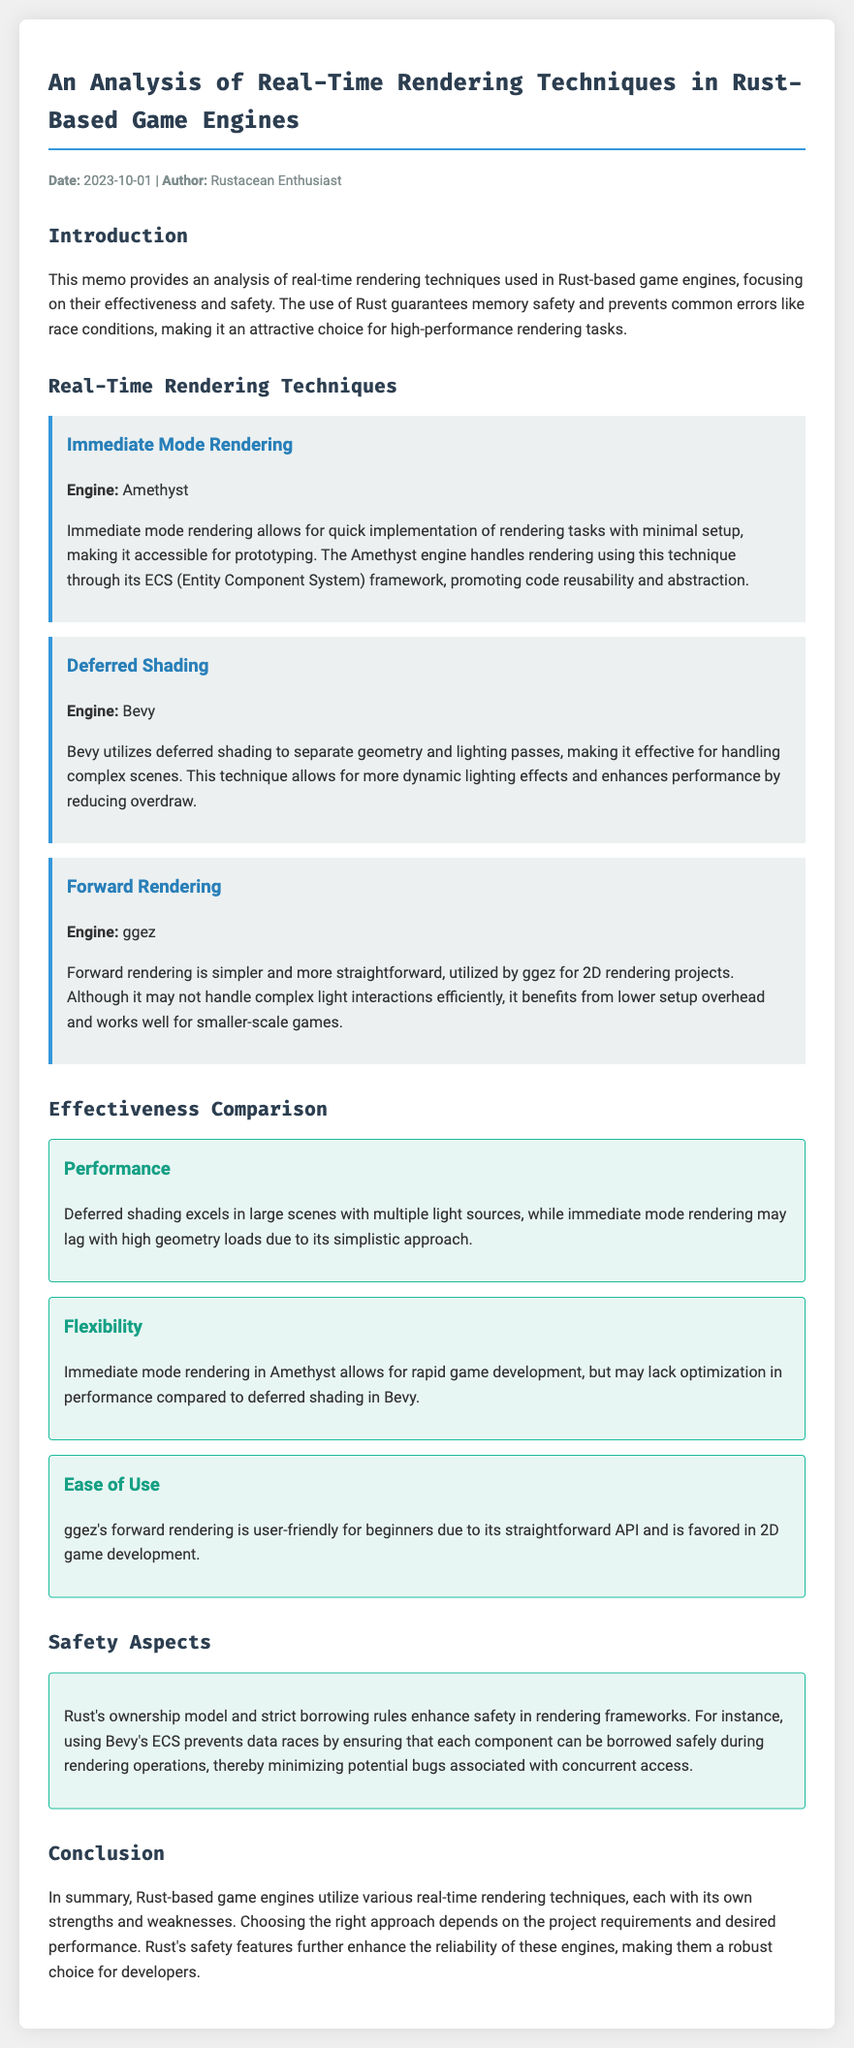What is the date of the memo? The date mentioned in the memo is at the top in the meta section.
Answer: 2023-10-01 Who is the author of the memo? The author's name is listed in the meta section at the top of the document.
Answer: Rustacean Enthusiast Which game engine uses Immediate Mode Rendering? The specific engine is mentioned alongside the rendering technique in the document.
Answer: Amethyst What is the main advantage of Deferred Shading? This advantage is discussed under the effectiveness section and considers performance factors.
Answer: Dynamic lighting effects What type of rendering does ggez utilize? The type of rendering used by ggez is explicitly stated in the corresponding technique section.
Answer: Forward Rendering Which technique is favored in 2D game development? The memo mentions this preference while discussing the ease of use of Forward Rendering.
Answer: ggez's forward rendering What safety feature does Rust provide for rendering frameworks? The memo discusses Rust's features in the context of safety under the Safety Aspects section.
Answer: Ownership model Which rendering technique may lag with high geometry loads? This information is detailed in the effectiveness comparison section of the memo.
Answer: Immediate Mode Rendering 